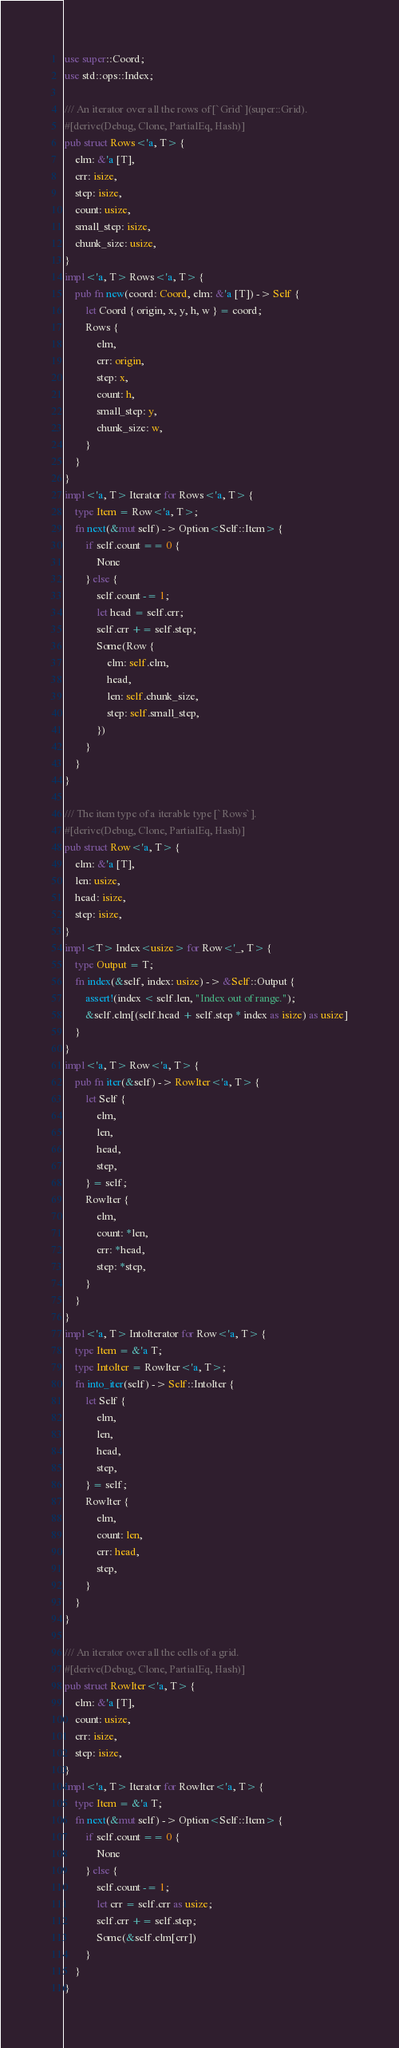<code> <loc_0><loc_0><loc_500><loc_500><_Rust_>use super::Coord;
use std::ops::Index;

/// An iterator over all the rows of [`Grid`](super::Grid).
#[derive(Debug, Clone, PartialEq, Hash)]
pub struct Rows<'a, T> {
    elm: &'a [T],
    crr: isize,
    step: isize,
    count: usize,
    small_step: isize,
    chunk_size: usize,
}
impl<'a, T> Rows<'a, T> {
    pub fn new(coord: Coord, elm: &'a [T]) -> Self {
        let Coord { origin, x, y, h, w } = coord;
        Rows {
            elm,
            crr: origin,
            step: x,
            count: h,
            small_step: y,
            chunk_size: w,
        }
    }
}
impl<'a, T> Iterator for Rows<'a, T> {
    type Item = Row<'a, T>;
    fn next(&mut self) -> Option<Self::Item> {
        if self.count == 0 {
            None
        } else {
            self.count -= 1;
            let head = self.crr;
            self.crr += self.step;
            Some(Row {
                elm: self.elm,
                head,
                len: self.chunk_size,
                step: self.small_step,
            })
        }
    }
}

/// The item type of a iterable type [`Rows`].
#[derive(Debug, Clone, PartialEq, Hash)]
pub struct Row<'a, T> {
    elm: &'a [T],
    len: usize,
    head: isize,
    step: isize,
}
impl<T> Index<usize> for Row<'_, T> {
    type Output = T;
    fn index(&self, index: usize) -> &Self::Output {
        assert!(index < self.len, "Index out of range.");
        &self.elm[(self.head + self.step * index as isize) as usize]
    }
}
impl<'a, T> Row<'a, T> {
    pub fn iter(&self) -> RowIter<'a, T> {
        let Self {
            elm,
            len,
            head,
            step,
        } = self;
        RowIter {
            elm,
            count: *len,
            crr: *head,
            step: *step,
        }
    }
}
impl<'a, T> IntoIterator for Row<'a, T> {
    type Item = &'a T;
    type IntoIter = RowIter<'a, T>;
    fn into_iter(self) -> Self::IntoIter {
        let Self {
            elm,
            len,
            head,
            step,
        } = self;
        RowIter {
            elm,
            count: len,
            crr: head,
            step,
        }
    }
}

/// An iterator over all the cells of a grid.
#[derive(Debug, Clone, PartialEq, Hash)]
pub struct RowIter<'a, T> {
    elm: &'a [T],
    count: usize,
    crr: isize,
    step: isize,
}
impl<'a, T> Iterator for RowIter<'a, T> {
    type Item = &'a T;
    fn next(&mut self) -> Option<Self::Item> {
        if self.count == 0 {
            None
        } else {
            self.count -= 1;
            let crr = self.crr as usize;
            self.crr += self.step;
            Some(&self.elm[crr])
        }
    }
}
</code> 